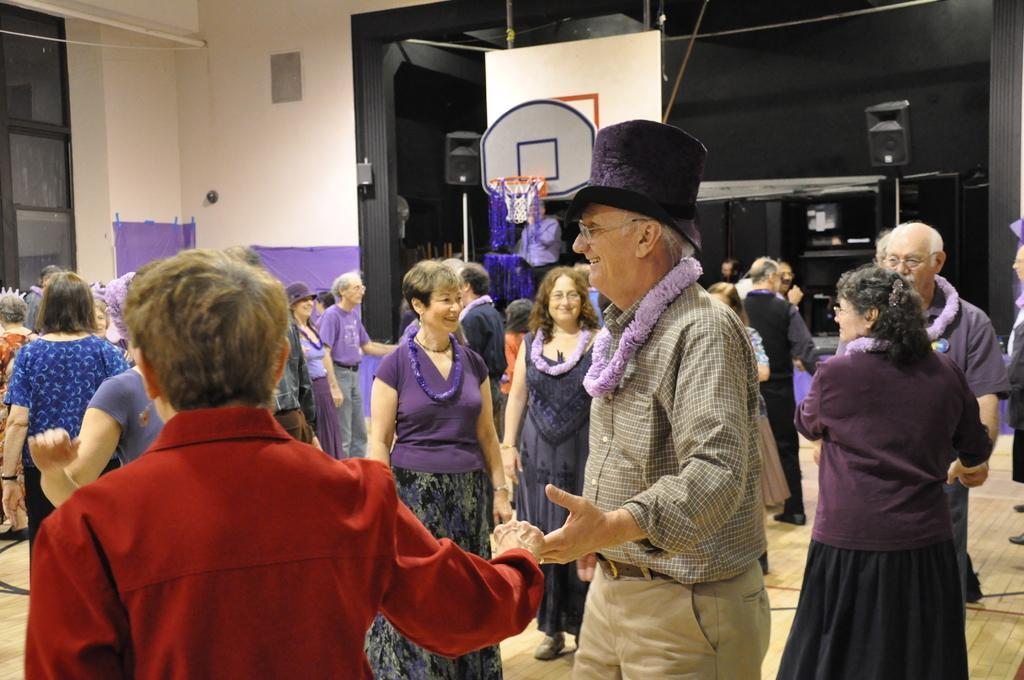Please provide a concise description of this image. In this image people are dancing in a hall,in background there is a wall and a glass door. 